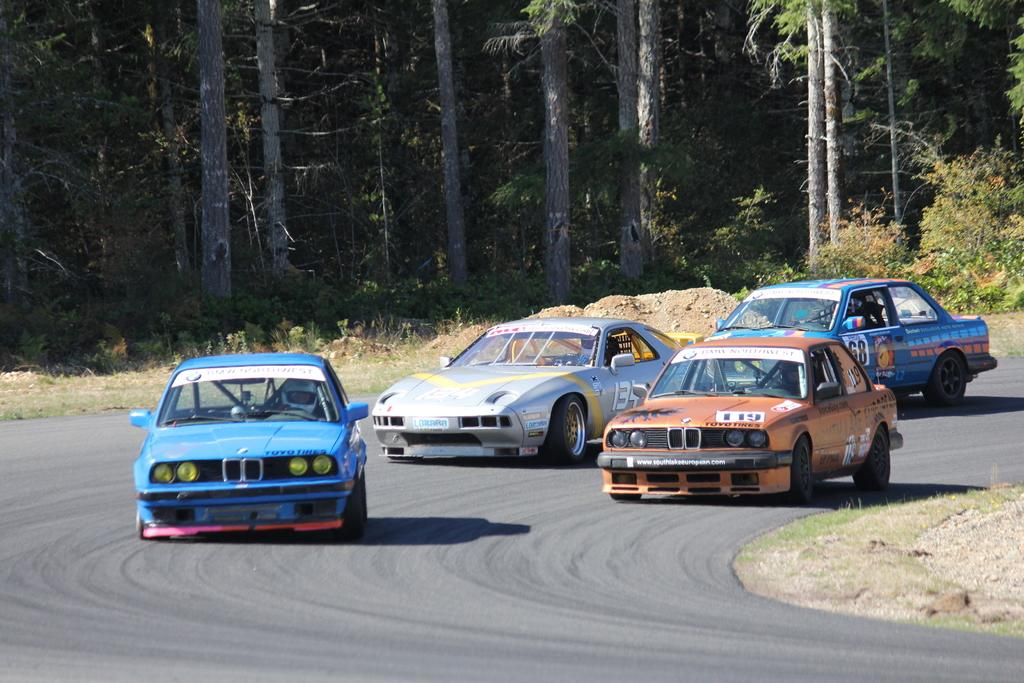What are the people in the image doing? The people in the image are riding cars. Where are the cars located? The cars are on a road. What can be seen in the background of the image? There are trees, plants, and grass in the background of the image. Where is the nest of pizzas located in the image? There is no nest or pizzas present in the image. 